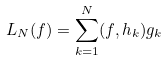Convert formula to latex. <formula><loc_0><loc_0><loc_500><loc_500>L _ { N } ( f ) = \sum _ { k = 1 } ^ { N } ( f , h _ { k } ) g _ { k }</formula> 